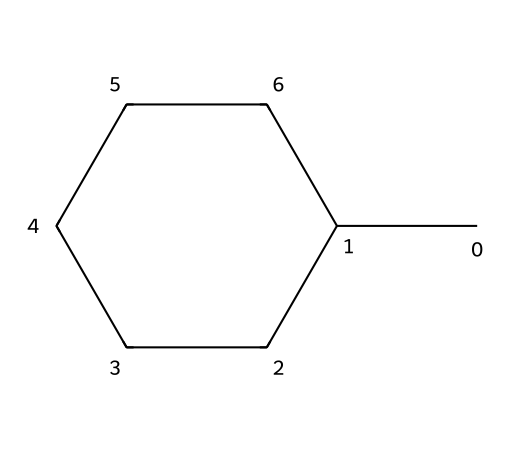What is the chemical name of this structure? The SMILES representation CC1CCCCC1 corresponds to a cycloalkane with a methyl group. The name of this molecule is methylcyclohexane, as it consists of a six-membered carbon ring (cyclohexane) with a methyl group (CH3) attached to one of the ring's carbon atoms.
Answer: methylcyclohexane How many carbon atoms are in the structure? The SMILES notation consists of 7 carbon letters (C), indicating that there are a total of 7 carbon atoms in the methylcyclohexane structure — 6 from the cyclohexane ring and 1 from the methyl group.
Answer: 7 What is the shape of methylcyclohexane? Methylcyclohexane is a cycloalkane, which typically adopts a chair conformation to minimize steric strain and angles, leading to a non-planar, three-dimensional shape that is most stable for the structure.
Answer: chair How many hydrogen atoms are connected to the black carbons? To determine the number of hydrogen atoms, we can use the general formula for cycloalkanes, CnH2n, where n is the number of carbon atoms. For methylcyclohexane (7 carbons), the total number of hydrogen atoms is 2*7 = 14, but since the ring structure has one substituent (the methyl group), we subtract 2 hydrogens (one from the ring and one added for the substituent), resulting in 14 - 2 = 12.
Answer: 12 Is methylcyclohexane a saturated or unsaturated hydrocarbon? Methylcyclohexane, being a cyclic structure with single bonds only (based on the SMILES representation), has no double or triple bonds, making it a saturated hydrocarbon because it contains the maximum number of hydrogen atoms attached to its carbon framework.
Answer: saturated What is one primary use of methylcyclohexane in marine engines? Methylcyclohexane is often utilized as a solvent or lubricant due to its relatively low viscosity and ability to reduce friction in engine components, thereby improving performance and efficiency.
Answer: lubricant 